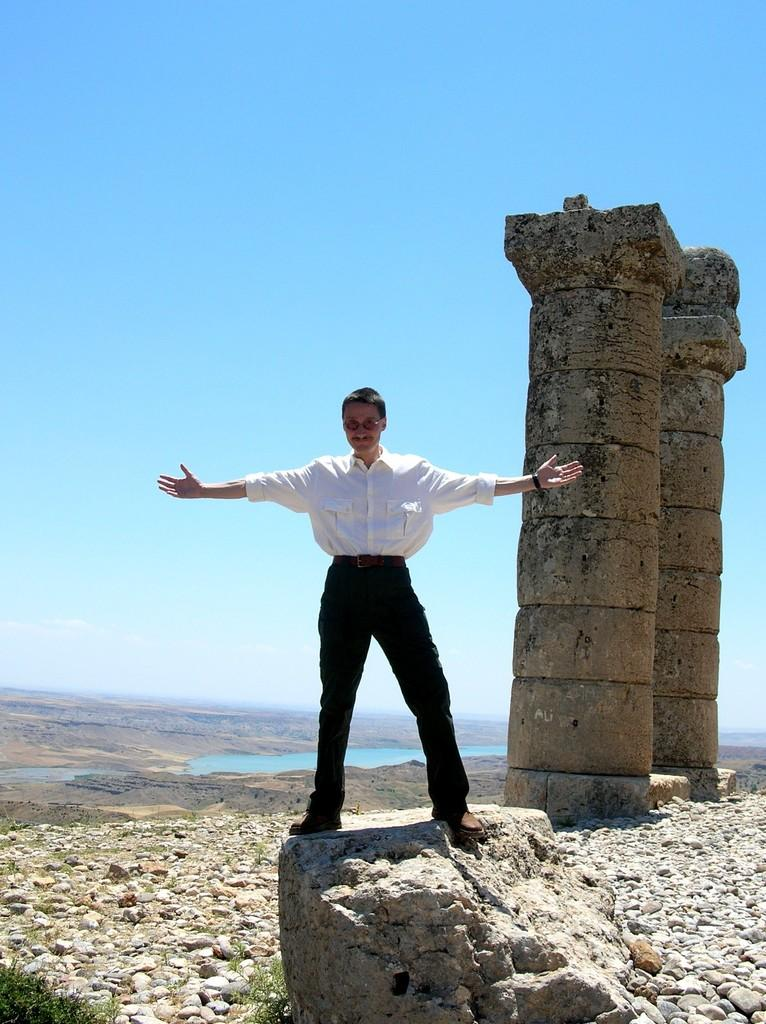What is the person in the image doing? The person is standing on a rock in the image. What structures can be seen in the image? There are two pillars visible in the image. What type of natural formations are present in the image? There are rocks and mountains in the image. What type of noise can be heard coming from the downtown area in the image? There is no downtown area present in the image, and therefore no noise can be heard from it. 